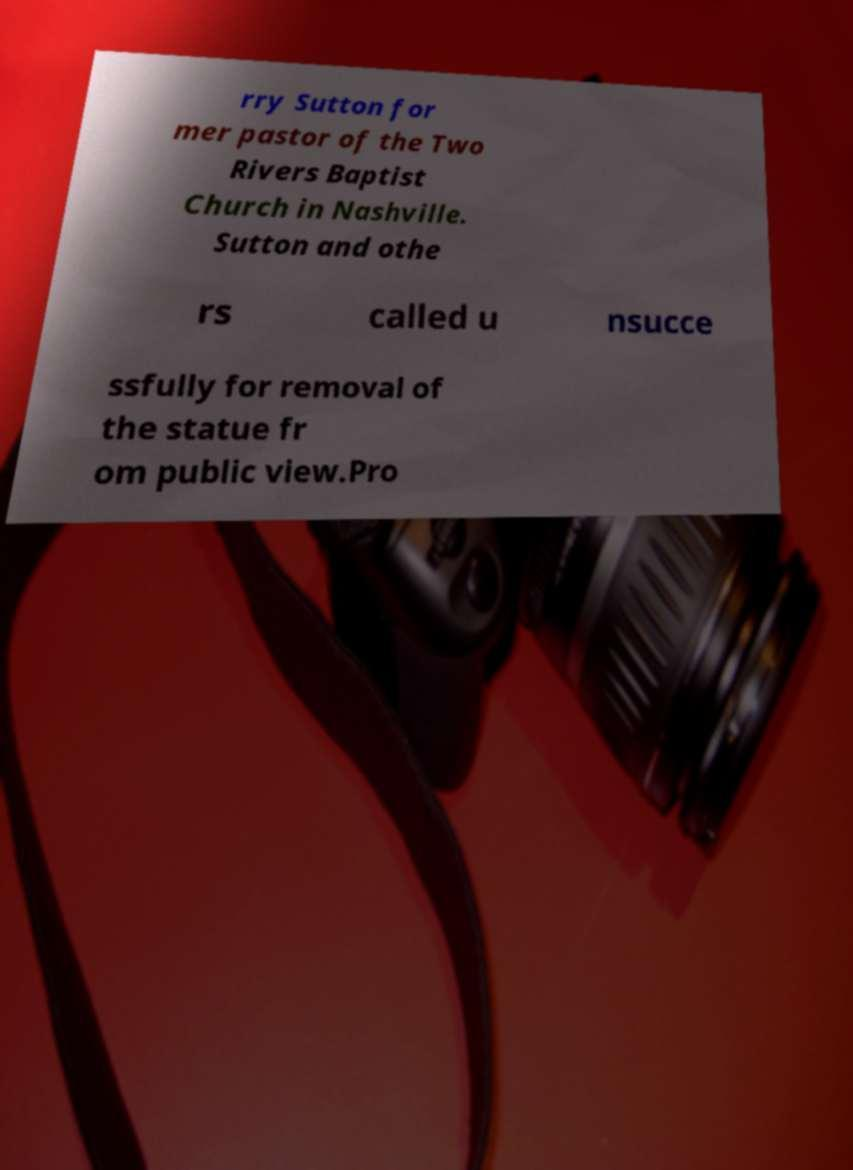There's text embedded in this image that I need extracted. Can you transcribe it verbatim? rry Sutton for mer pastor of the Two Rivers Baptist Church in Nashville. Sutton and othe rs called u nsucce ssfully for removal of the statue fr om public view.Pro 